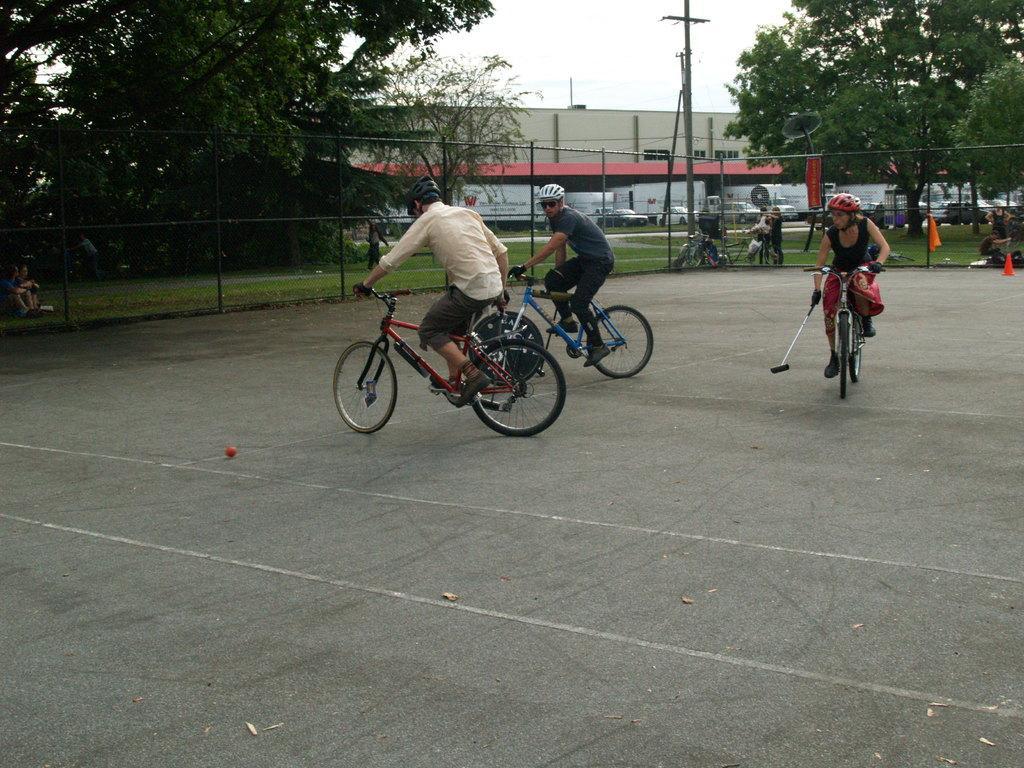Describe this image in one or two sentences. In this picture, we see three people are riding the bicycles. At the bottom, we see the road and a ball in red color. Behind them, we see a fence. Behind that, we see an electric pole and people are standing beside the pole. There are trees and buildings in the background. We even see cars parked on the road. On the left side, we see people are sitting on the grass field. At the top, we see the sky. 